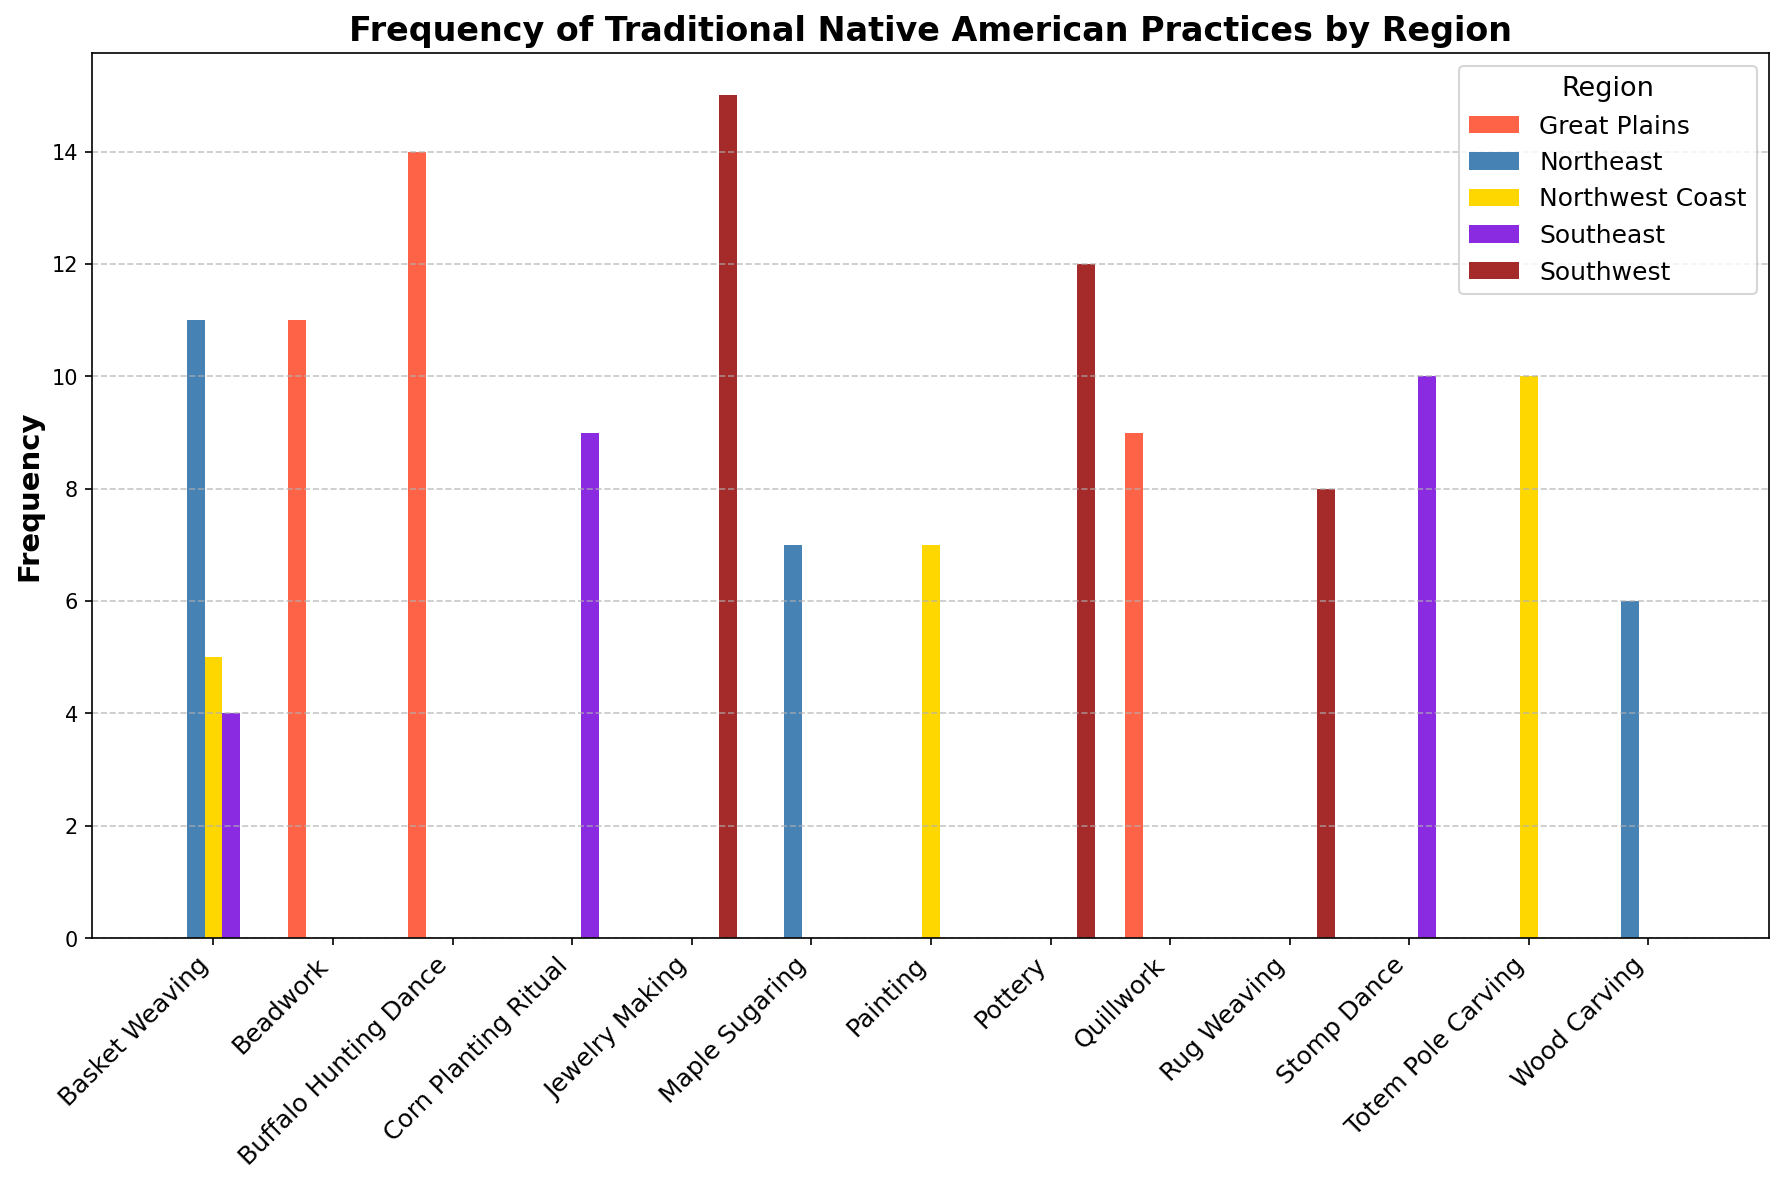What is the most frequent traditional practice in the Northeast region? To determine the most frequent practice in the Northeast region, look at the bars labeled for the Northeast in the histogram. The tallest bar in the Northeast region is "Basket Weaving" with a frequency of 11.
Answer: Basket Weaving Which region has the highest frequency for Pottery, and what is that frequency? To find this, look at the bar corresponding to "Pottery" across regions. The Southwest region has the highest frequency for Pottery, which is 12.
Answer: Southwest, 12 What is the combined frequency of Jewelry Making, Beadwork, and Totem Pole Carving? To find the combined frequency, add the frequencies of Jewelry Making (15), Beadwork (11), and Totem Pole Carving (10). The combined frequency is 15 + 11 + 10 = 36.
Answer: 36 Which traditional practice is least frequent in the Southeast region, and what is its frequency? To find the least frequent practice in the Southeast, compare the heights of the bars for the Southeast practices. "Basket Weaving" is the least frequent with a frequency of 4.
Answer: Basket Weaving, 4 How many traditional practices have a frequency of at least 10 in any region? Count the number of bars in the histogram that have a height of 10 or more: Pottery (12), Jewelry Making (15), Totem Pole Carving (10), Buffalo Hunting Dance (14), Beadwork (11), Basket Weaving (11), and Stomp Dance (10). There are 7 practices.
Answer: 7 Compare the total frequency of Basket Weaving across all regions. Sum the frequencies of Basket Weaving for the Southwest (0), Northwest Coast (5), Northeast (11), and Southeast (4). The total frequency is 0 + 5 + 11 + 4 = 20.
Answer: 20 What is the frequency difference between Wood Carving in the Northeast region and Basket Weaving in the Northwest Coast region? To find the difference, subtract the frequency of Basket Weaving in the Northwest Coast (5) from the frequency of Wood Carving in the Northeast (6). The difference is 6 - 5 = 1.
Answer: 1 